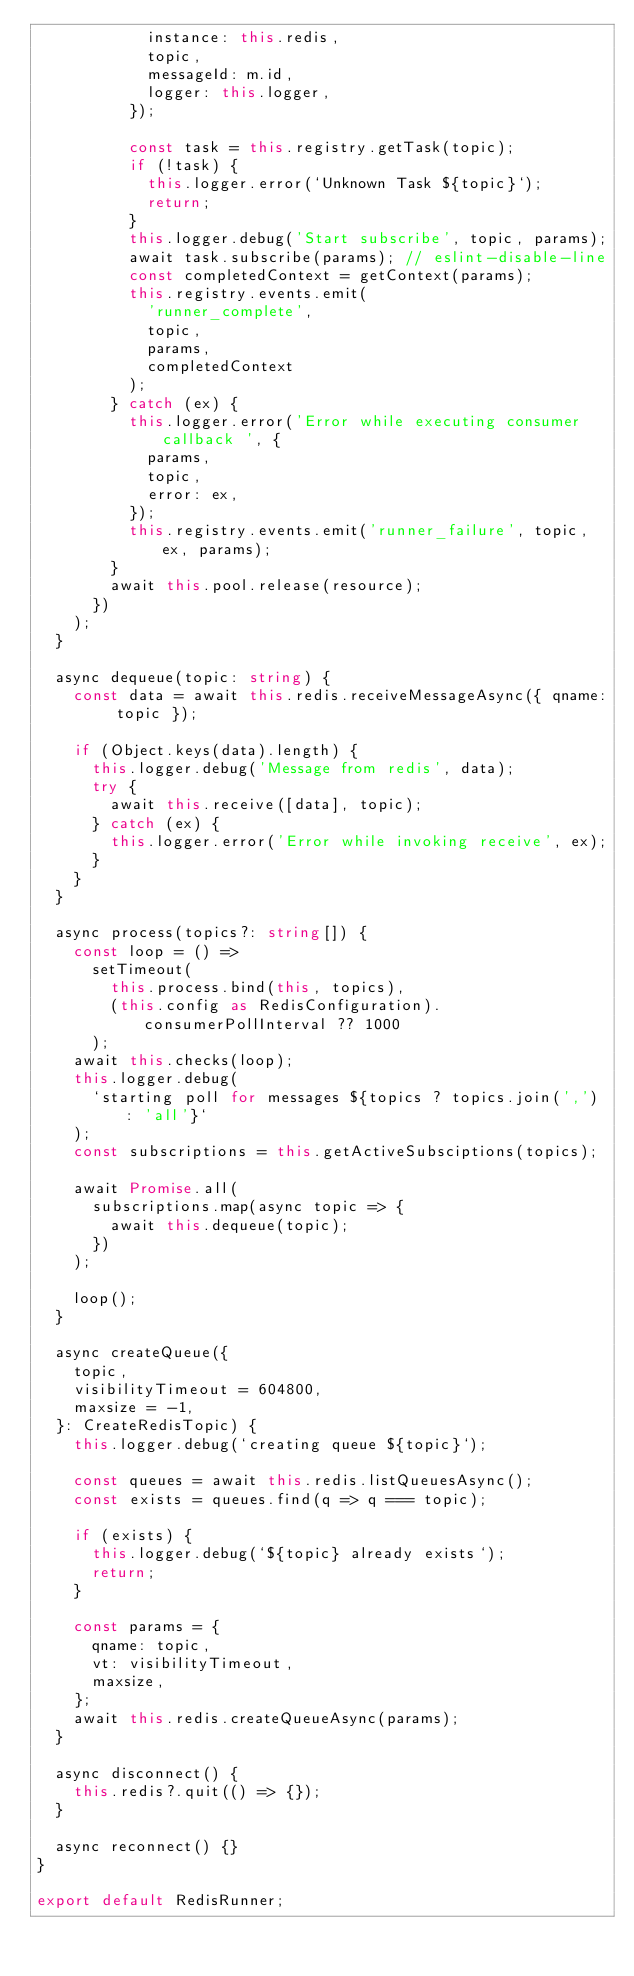Convert code to text. <code><loc_0><loc_0><loc_500><loc_500><_TypeScript_>            instance: this.redis,
            topic,
            messageId: m.id,
            logger: this.logger,
          });

          const task = this.registry.getTask(topic);
          if (!task) {
            this.logger.error(`Unknown Task ${topic}`);
            return;
          }
          this.logger.debug('Start subscribe', topic, params);
          await task.subscribe(params); // eslint-disable-line
          const completedContext = getContext(params);
          this.registry.events.emit(
            'runner_complete',
            topic,
            params,
            completedContext
          );
        } catch (ex) {
          this.logger.error('Error while executing consumer callback ', {
            params,
            topic,
            error: ex,
          });
          this.registry.events.emit('runner_failure', topic, ex, params);
        }
        await this.pool.release(resource);
      })
    );
  }

  async dequeue(topic: string) {
    const data = await this.redis.receiveMessageAsync({ qname: topic });

    if (Object.keys(data).length) {
      this.logger.debug('Message from redis', data);
      try {
        await this.receive([data], topic);
      } catch (ex) {
        this.logger.error('Error while invoking receive', ex);
      }
    }
  }

  async process(topics?: string[]) {
    const loop = () =>
      setTimeout(
        this.process.bind(this, topics),
        (this.config as RedisConfiguration).consumerPollInterval ?? 1000
      );
    await this.checks(loop);
    this.logger.debug(
      `starting poll for messages ${topics ? topics.join(',') : 'all'}`
    );
    const subscriptions = this.getActiveSubsciptions(topics);

    await Promise.all(
      subscriptions.map(async topic => {
        await this.dequeue(topic);
      })
    );

    loop();
  }

  async createQueue({
    topic,
    visibilityTimeout = 604800,
    maxsize = -1,
  }: CreateRedisTopic) {
    this.logger.debug(`creating queue ${topic}`);

    const queues = await this.redis.listQueuesAsync();
    const exists = queues.find(q => q === topic);

    if (exists) {
      this.logger.debug(`${topic} already exists`);
      return;
    }

    const params = {
      qname: topic,
      vt: visibilityTimeout,
      maxsize,
    };
    await this.redis.createQueueAsync(params);
  }

  async disconnect() {
    this.redis?.quit(() => {});
  }

  async reconnect() {}
}

export default RedisRunner;
</code> 